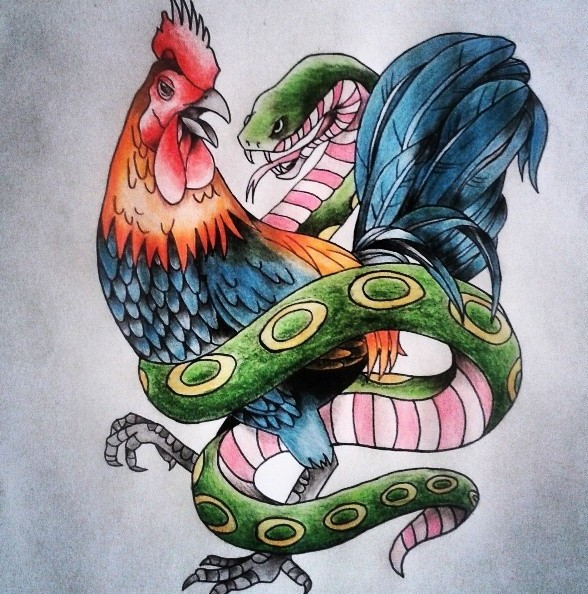What kind of message could be conveyed by depicting the rooster and the snake in such a vivid and intertwined manner? Depicting the rooster and the snake in such a vivid and intertwined manner could convey a message about the complexity of existence. It might illustrate that attributes we typically see as opposing—like vigilance and temptation, or life and death—are deeply interconnected. By intertwining these animals, the artist might be suggesting that these forces are not mutually exclusive but rather parts of a greater whole. The vivid colors and dramatic entanglement add to the intensity of this message, making it both visually and philosophically arresting. Could there be an underlying theme of unity or harmony in the conflict itself? Absolutely. Conflict often leads to a greater understanding and appreciation of balance. In this artwork, the unity of the rooster and snake—even in conflict—could indicate that opposing forces are necessary for harmony. Each needs the other to define itself, much like day defines night. The power of this piece could lie in showing that harmony is not the absence of conflict, but its synthesis. What if the rooster and the snake were legendary guardians of an ancient treasure? How does this affect your interpretation? If the rooster and the snake were legendary guardians of an ancient treasure, this would add a layer of narrative intrigue to the interpretation. They could represent the dual aspects of protection and secrecy. The rooster's vigilance would safeguard the treasure from human incursions at dawn, while the snake's presence would warn and deter those who might seek to steal it. This scenario turns the artwork into a story of guardianship, where the intertwining of these creatures highlights their combined strength and vigilance, and the preciousness of what they protect. 